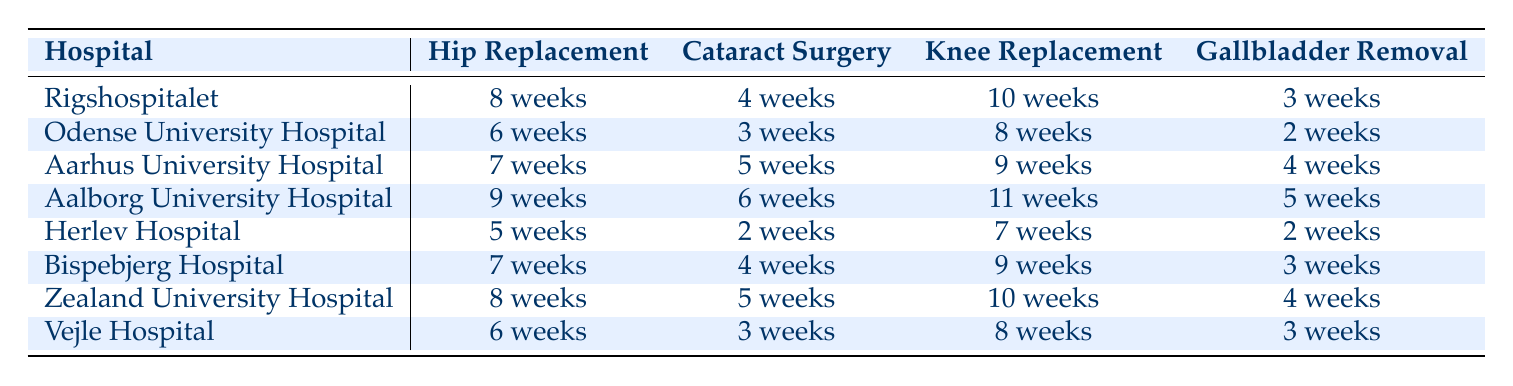What is the waiting time for cataract surgery at Herlev Hospital? The table indicates that the waiting time for cataract surgery at Herlev Hospital is 2 weeks.
Answer: 2 weeks Which hospital has the shortest waiting time for gallbladder removal? By examining the table, Odense University Hospital and Herlev Hospital both have the shortest waiting time of 2 weeks for gallbladder removal.
Answer: Odense University Hospital and Herlev Hospital What is the difference in waiting time for hip replacement between Aalborg University Hospital and Odense University Hospital? The waiting time for hip replacement at Odense University Hospital is 6 weeks, while at Aalborg University Hospital it is 9 weeks. The difference is 9 weeks - 6 weeks = 3 weeks.
Answer: 3 weeks Is the waiting time for knee replacement at Aarhus University Hospital greater than that at Vejle Hospital? The waiting time for knee replacement at Aarhus University Hospital is 9 weeks and 8 weeks at Vejle Hospital. Since 9 weeks is greater than 8 weeks, the statement is true.
Answer: Yes What is the average waiting time for hip replacement across all hospitals listed? The waiting times for hip replacement are 8, 6, 7, 9, 5, 7, 8, and 6 weeks. Summing these gives 56 weeks. There are 8 hospitals, so the average is 56 weeks / 8 = 7 weeks.
Answer: 7 weeks Which hospital has the longest waiting time for knee replacement, and what is that time? Looking through the table, Aalborg University Hospital shows the longest waiting time of 11 weeks for knee replacement.
Answer: Aalborg University Hospital, 11 weeks What is the waiting time for cataract surgery at Zealand University Hospital? The table shows that the waiting time for cataract surgery at Zealand University Hospital is 5 weeks.
Answer: 5 weeks Are the waiting times for gallbladder removal at Rigshospitalet and Zealand University Hospital the same? Rigshospitalet has a waiting time of 3 weeks, whereas Zealand University Hospital has 4 weeks. Since these times are not equal, the answer is no.
Answer: No 